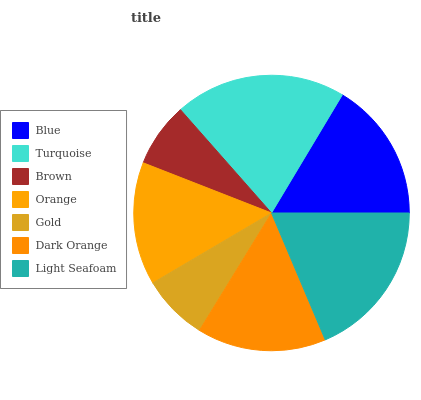Is Brown the minimum?
Answer yes or no. Yes. Is Turquoise the maximum?
Answer yes or no. Yes. Is Turquoise the minimum?
Answer yes or no. No. Is Brown the maximum?
Answer yes or no. No. Is Turquoise greater than Brown?
Answer yes or no. Yes. Is Brown less than Turquoise?
Answer yes or no. Yes. Is Brown greater than Turquoise?
Answer yes or no. No. Is Turquoise less than Brown?
Answer yes or no. No. Is Dark Orange the high median?
Answer yes or no. Yes. Is Dark Orange the low median?
Answer yes or no. Yes. Is Orange the high median?
Answer yes or no. No. Is Brown the low median?
Answer yes or no. No. 